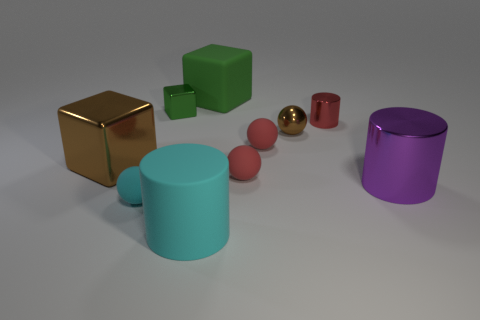Does the large brown shiny object have the same shape as the big green rubber object? Both objects appear to be cube-shaped, indicating that the large brown shiny object indeed shares the same general cube shape as the big green rubber object. However, upon closer inspection, the dimensions and exact proportions of the objects might vary slightly, as is often the case with real-world objects. 